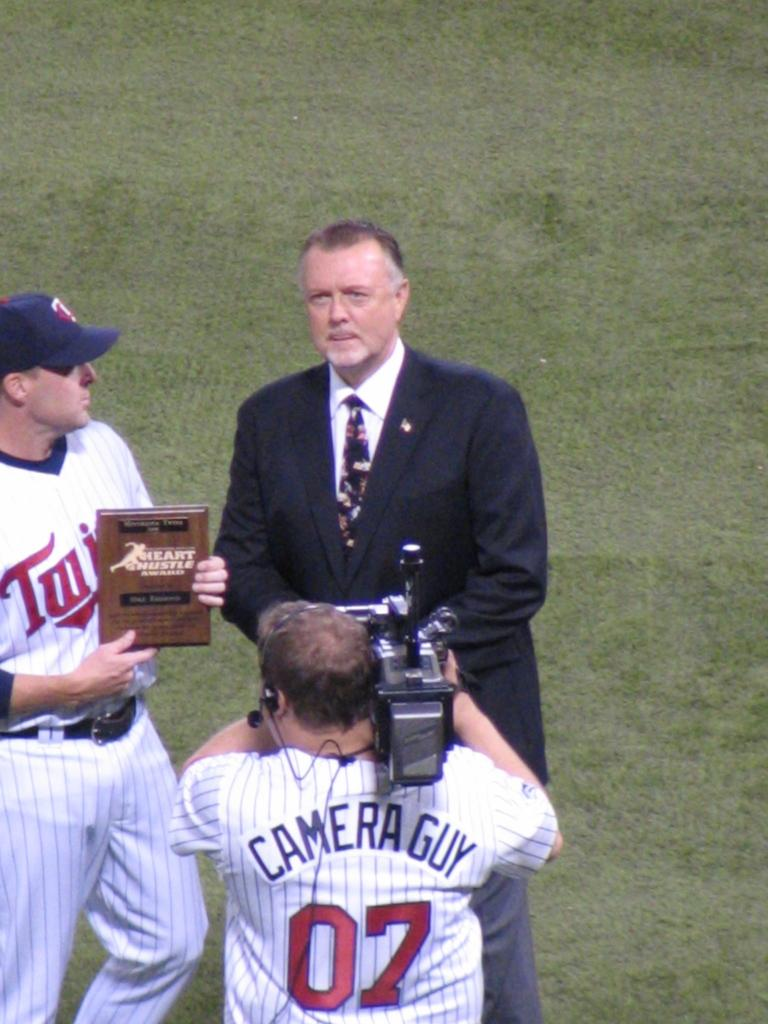Provide a one-sentence caption for the provided image. A camera guy has a sports jersey that says "Camera Guy" on the back. 